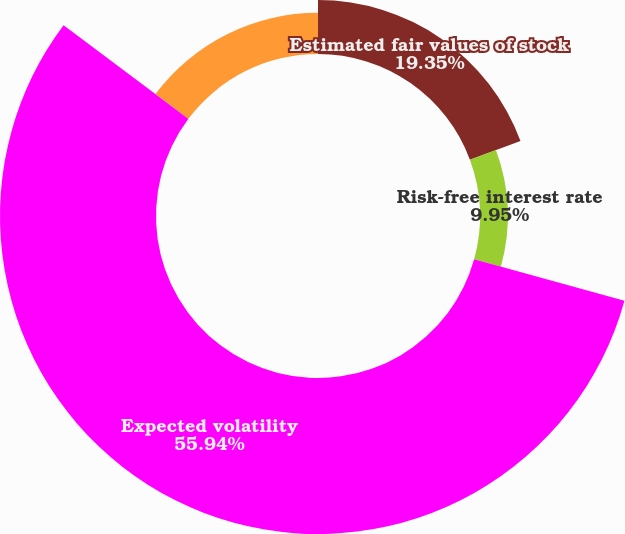<chart> <loc_0><loc_0><loc_500><loc_500><pie_chart><fcel>Estimated fair values of stock<fcel>Risk-free interest rate<fcel>Expected volatility<fcel>Dividend yield<nl><fcel>19.35%<fcel>9.95%<fcel>55.94%<fcel>14.76%<nl></chart> 